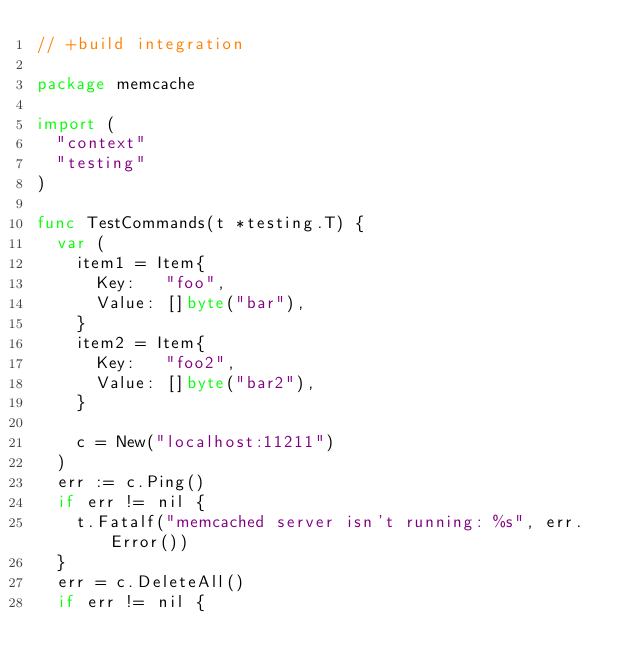<code> <loc_0><loc_0><loc_500><loc_500><_Go_>// +build integration

package memcache

import (
	"context"
	"testing"
)

func TestCommands(t *testing.T) {
	var (
		item1 = Item{
			Key:   "foo",
			Value: []byte("bar"),
		}
		item2 = Item{
			Key:   "foo2",
			Value: []byte("bar2"),
		}

		c = New("localhost:11211")
	)
	err := c.Ping()
	if err != nil {
		t.Fatalf("memcached server isn't running: %s", err.Error())
	}
	err = c.DeleteAll()
	if err != nil {</code> 